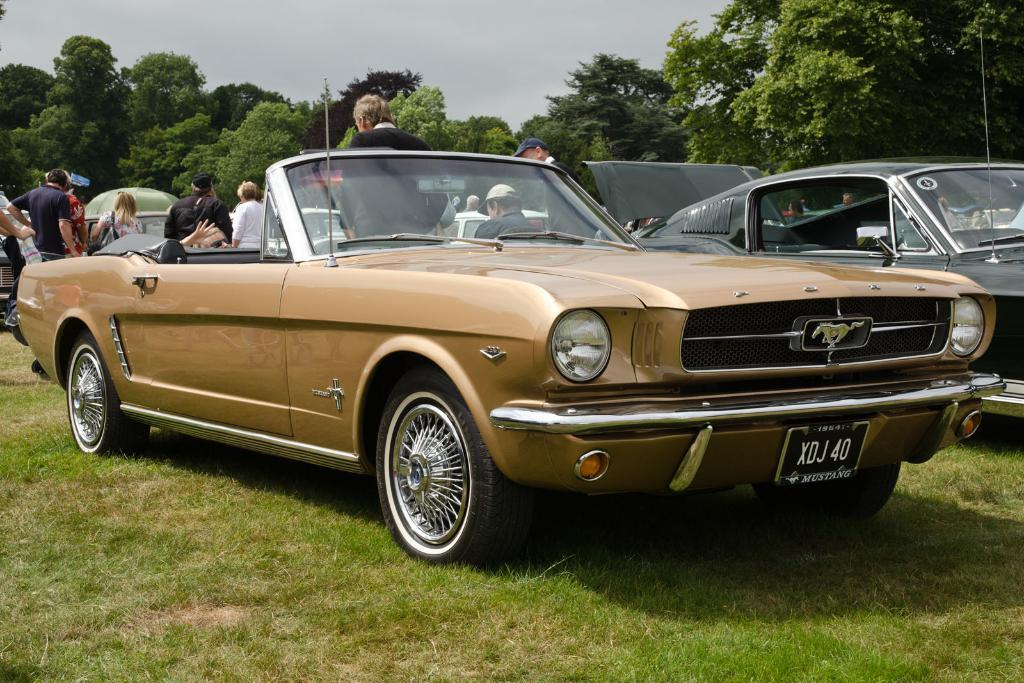What can be seen in the background of the image? There is a sky and trees visible in the background of the image. Who or what is present in the image? There are people and vehicles in the image. What features are visible on the vehicles? Headlights and number plates are visible on the vehicles. What type of vegetation is present in the image? There is grass in the image. Can you see a worm crawling on the grass in the image? There is no worm visible in the image; it only shows people, vehicles, and grass. Is there a cemetery in the background of the image? There is no cemetery present in the image; it features a sky, trees, and grass. 